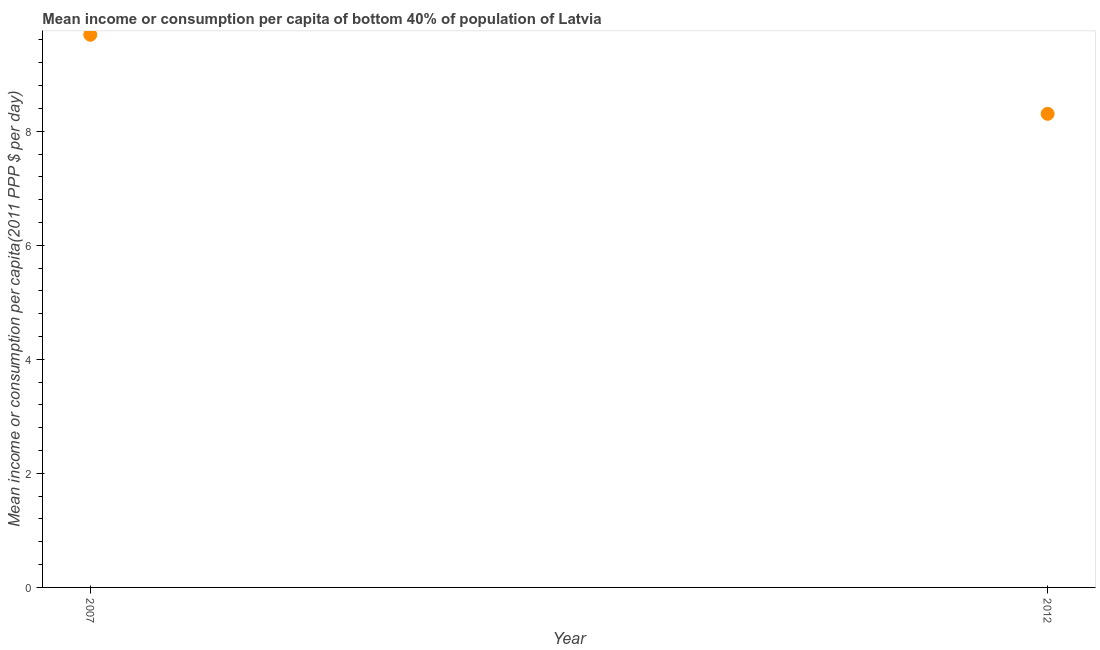What is the mean income or consumption in 2007?
Give a very brief answer. 9.69. Across all years, what is the maximum mean income or consumption?
Offer a terse response. 9.69. Across all years, what is the minimum mean income or consumption?
Provide a short and direct response. 8.31. What is the sum of the mean income or consumption?
Your response must be concise. 18. What is the difference between the mean income or consumption in 2007 and 2012?
Make the answer very short. 1.39. What is the average mean income or consumption per year?
Ensure brevity in your answer.  9. What is the median mean income or consumption?
Make the answer very short. 9. In how many years, is the mean income or consumption greater than 3.6 $?
Keep it short and to the point. 2. What is the ratio of the mean income or consumption in 2007 to that in 2012?
Offer a very short reply. 1.17. Does the mean income or consumption monotonically increase over the years?
Offer a very short reply. No. How many dotlines are there?
Your answer should be very brief. 1. How many years are there in the graph?
Your response must be concise. 2. Does the graph contain any zero values?
Your answer should be very brief. No. Does the graph contain grids?
Your answer should be compact. No. What is the title of the graph?
Your answer should be very brief. Mean income or consumption per capita of bottom 40% of population of Latvia. What is the label or title of the X-axis?
Your answer should be very brief. Year. What is the label or title of the Y-axis?
Keep it short and to the point. Mean income or consumption per capita(2011 PPP $ per day). What is the Mean income or consumption per capita(2011 PPP $ per day) in 2007?
Your answer should be compact. 9.69. What is the Mean income or consumption per capita(2011 PPP $ per day) in 2012?
Your answer should be compact. 8.31. What is the difference between the Mean income or consumption per capita(2011 PPP $ per day) in 2007 and 2012?
Your answer should be compact. 1.39. What is the ratio of the Mean income or consumption per capita(2011 PPP $ per day) in 2007 to that in 2012?
Your response must be concise. 1.17. 